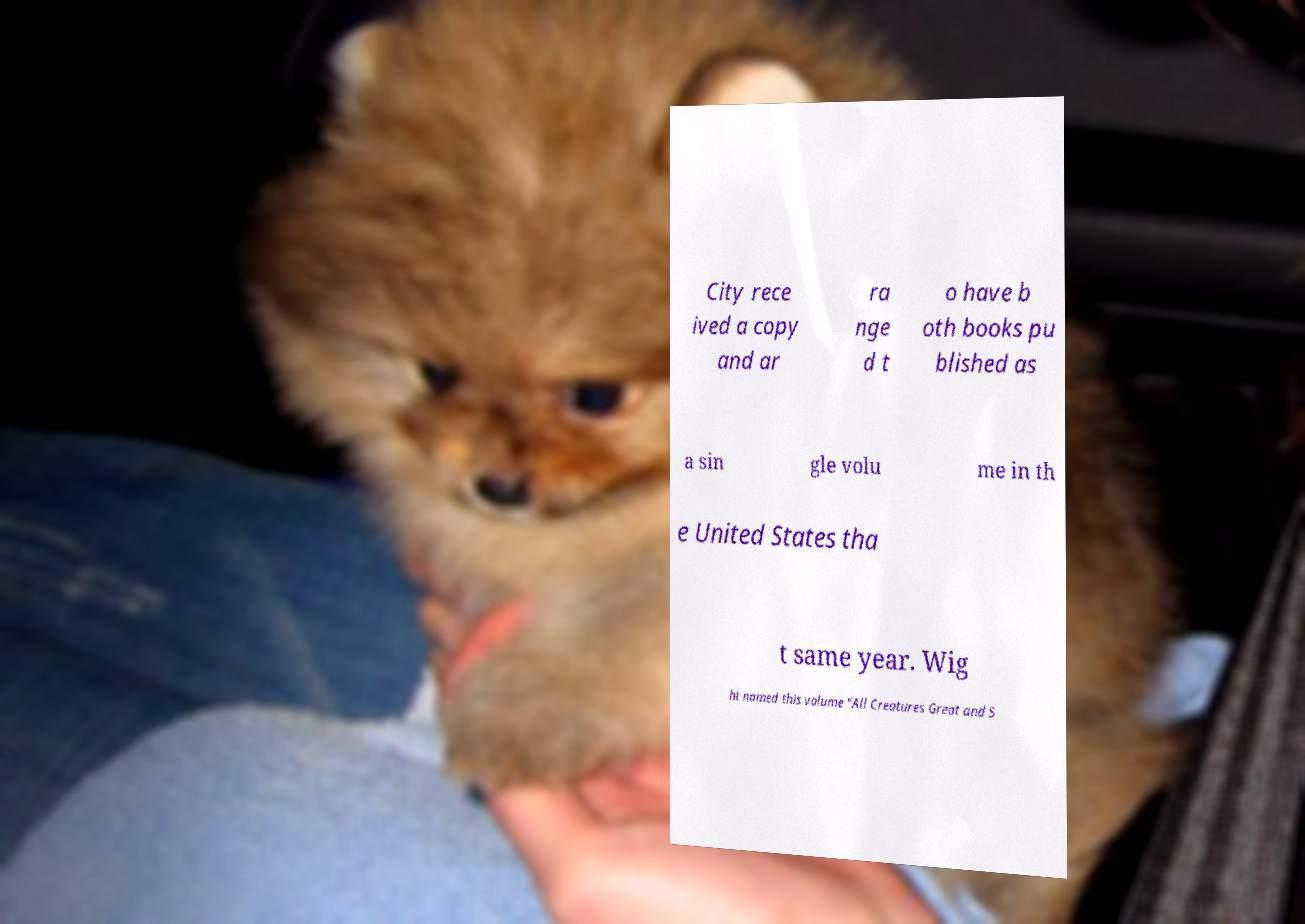For documentation purposes, I need the text within this image transcribed. Could you provide that? City rece ived a copy and ar ra nge d t o have b oth books pu blished as a sin gle volu me in th e United States tha t same year. Wig ht named this volume "All Creatures Great and S 